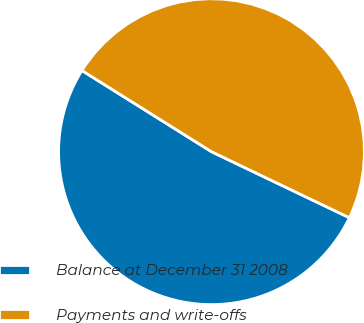Convert chart. <chart><loc_0><loc_0><loc_500><loc_500><pie_chart><fcel>Balance at December 31 2008<fcel>Payments and write-offs<nl><fcel>51.8%<fcel>48.2%<nl></chart> 